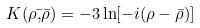Convert formula to latex. <formula><loc_0><loc_0><loc_500><loc_500>K ( \rho \bar { , } \bar { \rho } ) = - 3 \ln [ - i ( \rho - \bar { \rho } ) ]</formula> 